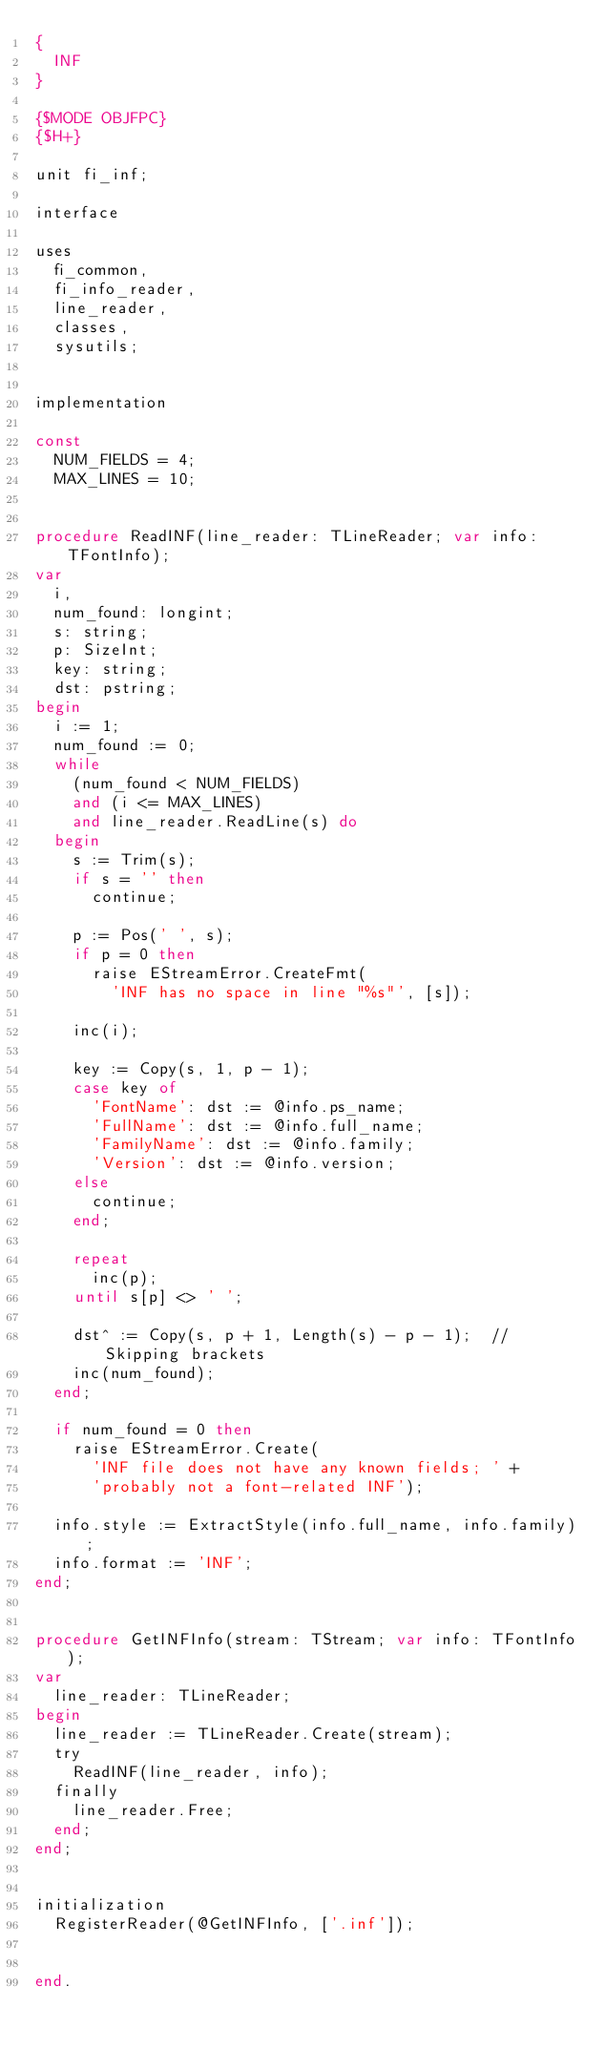<code> <loc_0><loc_0><loc_500><loc_500><_Pascal_>{
  INF
}

{$MODE OBJFPC}
{$H+}

unit fi_inf;

interface

uses
  fi_common,
  fi_info_reader,
  line_reader,
  classes,
  sysutils;


implementation

const
  NUM_FIELDS = 4;
  MAX_LINES = 10;


procedure ReadINF(line_reader: TLineReader; var info: TFontInfo);
var
  i,
  num_found: longint;
  s: string;
  p: SizeInt;
  key: string;
  dst: pstring;
begin
  i := 1;
  num_found := 0;
  while
    (num_found < NUM_FIELDS)
    and (i <= MAX_LINES)
    and line_reader.ReadLine(s) do
  begin
    s := Trim(s);
    if s = '' then
      continue;

    p := Pos(' ', s);
    if p = 0 then
      raise EStreamError.CreateFmt(
        'INF has no space in line "%s"', [s]);

    inc(i);

    key := Copy(s, 1, p - 1);
    case key of
      'FontName': dst := @info.ps_name;
      'FullName': dst := @info.full_name;
      'FamilyName': dst := @info.family;
      'Version': dst := @info.version;
    else
      continue;
    end;

    repeat
      inc(p);
    until s[p] <> ' ';

    dst^ := Copy(s, p + 1, Length(s) - p - 1);  // Skipping brackets
    inc(num_found);
  end;

  if num_found = 0 then
    raise EStreamError.Create(
      'INF file does not have any known fields; ' +
      'probably not a font-related INF');

  info.style := ExtractStyle(info.full_name, info.family);
  info.format := 'INF';
end;


procedure GetINFInfo(stream: TStream; var info: TFontInfo);
var
  line_reader: TLineReader;
begin
  line_reader := TLineReader.Create(stream);
  try
    ReadINF(line_reader, info);
  finally
    line_reader.Free;
  end;
end;


initialization
  RegisterReader(@GetINFInfo, ['.inf']);


end.
</code> 